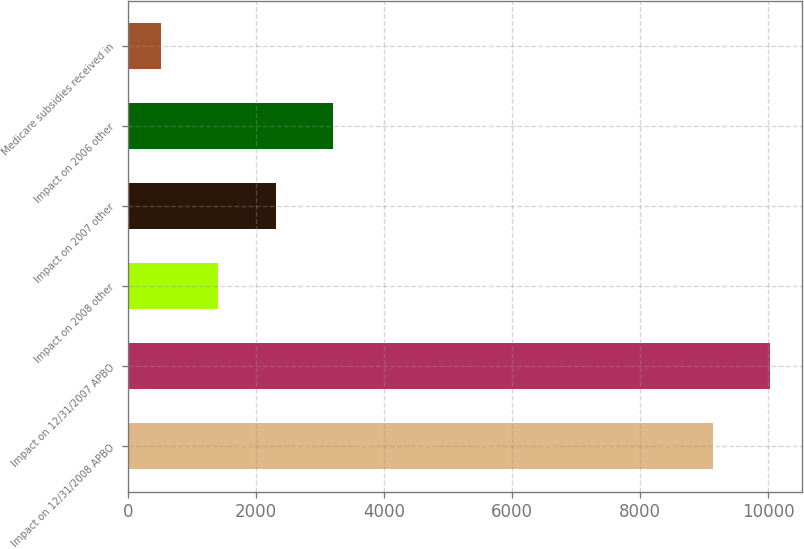<chart> <loc_0><loc_0><loc_500><loc_500><bar_chart><fcel>Impact on 12/31/2008 APBO<fcel>Impact on 12/31/2007 APBO<fcel>Impact on 2008 other<fcel>Impact on 2007 other<fcel>Impact on 2006 other<fcel>Medicare subsidies received in<nl><fcel>9135<fcel>10032.8<fcel>1406.8<fcel>2304.6<fcel>3202.4<fcel>509<nl></chart> 